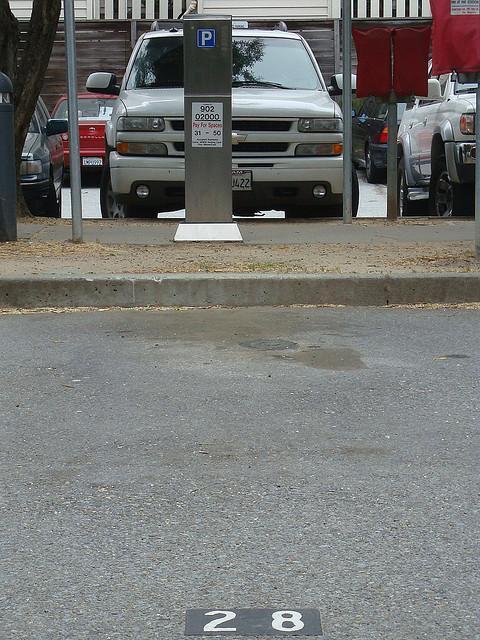How many motorcycles do you see?
Give a very brief answer. 0. How many cars are in the photo?
Give a very brief answer. 5. How many cars are in the image?
Give a very brief answer. 5. How many vehicles do you see?
Give a very brief answer. 5. How many cars are there?
Give a very brief answer. 5. 